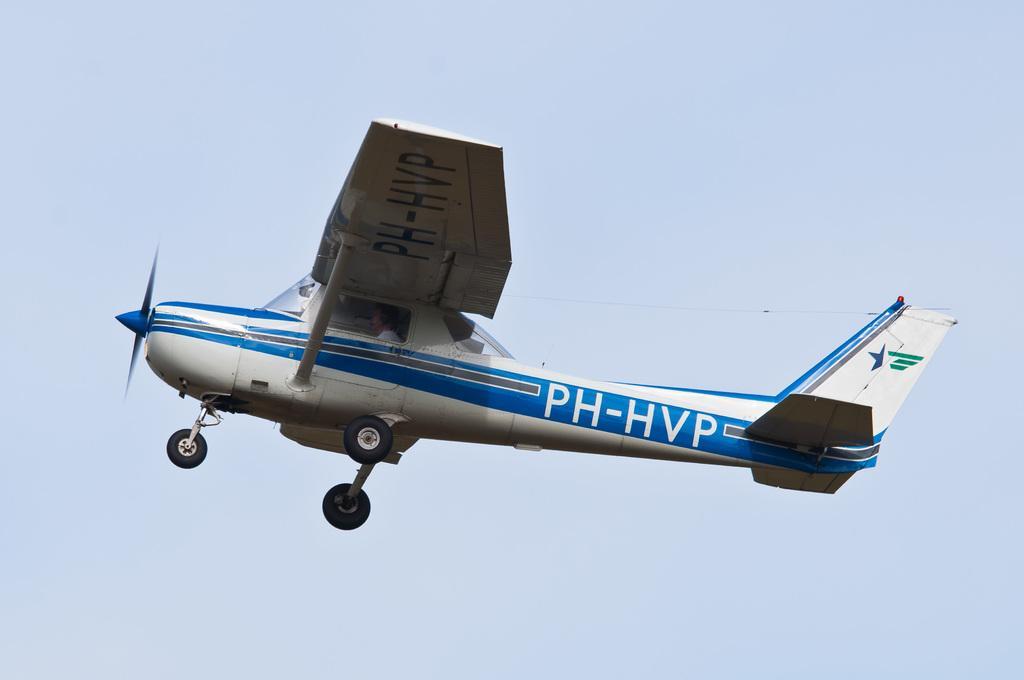Could you give a brief overview of what you see in this image? In this image we can see an aircraft and there is a person sitting inside the aircraft. We can see some text written on it and in the background, we can see the sky. 